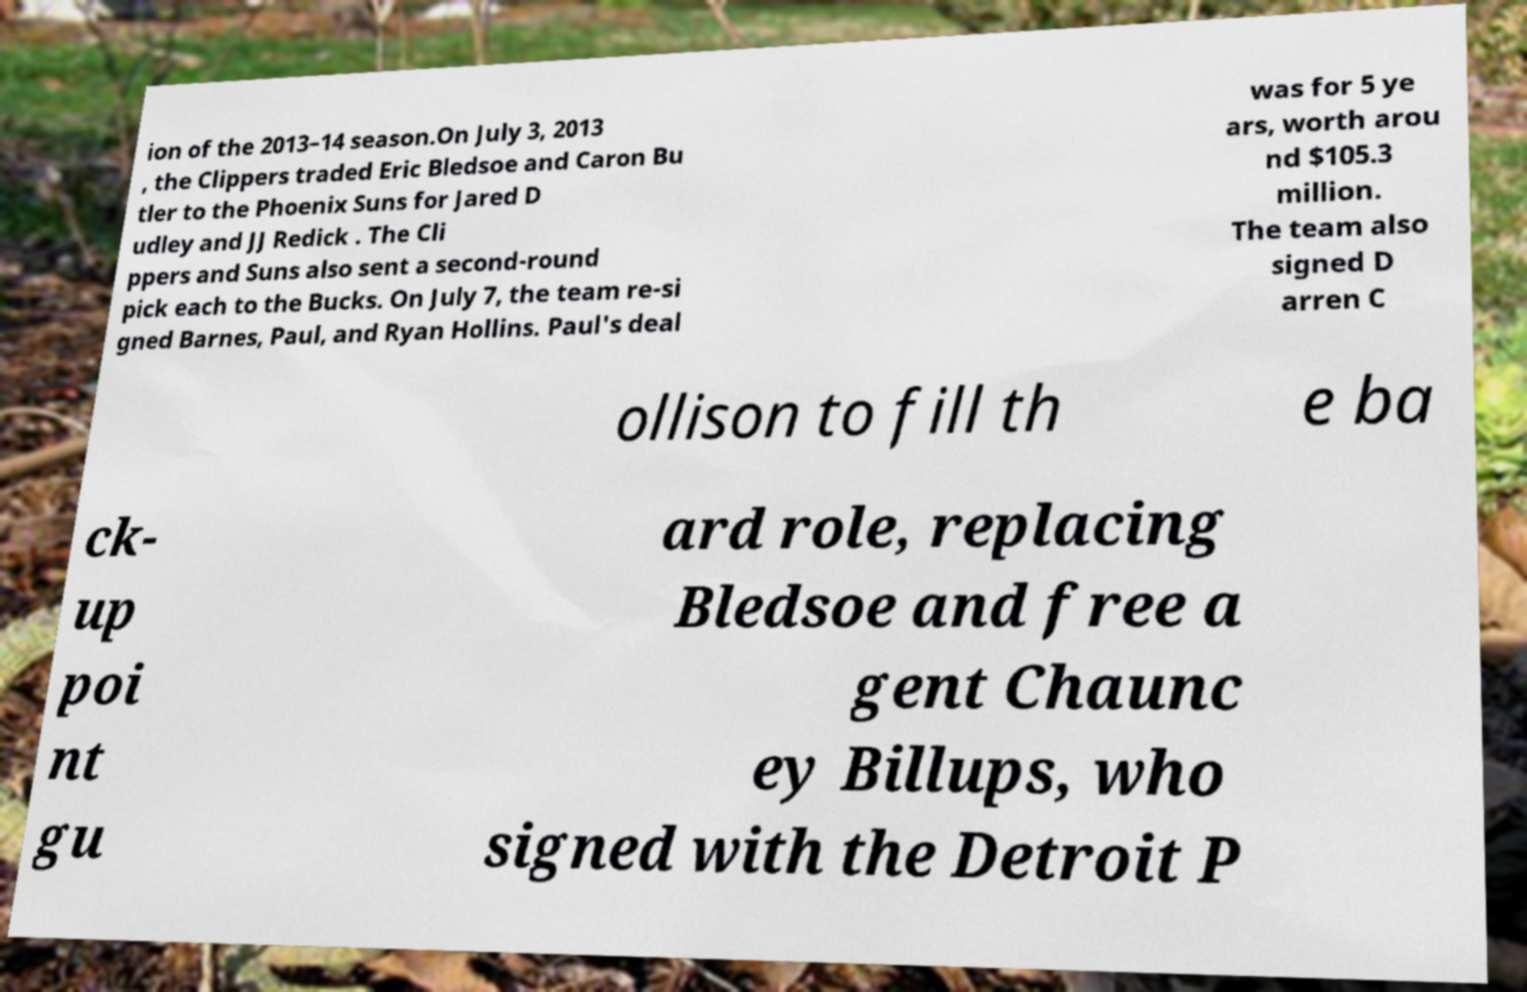For documentation purposes, I need the text within this image transcribed. Could you provide that? ion of the 2013–14 season.On July 3, 2013 , the Clippers traded Eric Bledsoe and Caron Bu tler to the Phoenix Suns for Jared D udley and JJ Redick . The Cli ppers and Suns also sent a second-round pick each to the Bucks. On July 7, the team re-si gned Barnes, Paul, and Ryan Hollins. Paul's deal was for 5 ye ars, worth arou nd $105.3 million. The team also signed D arren C ollison to fill th e ba ck- up poi nt gu ard role, replacing Bledsoe and free a gent Chaunc ey Billups, who signed with the Detroit P 